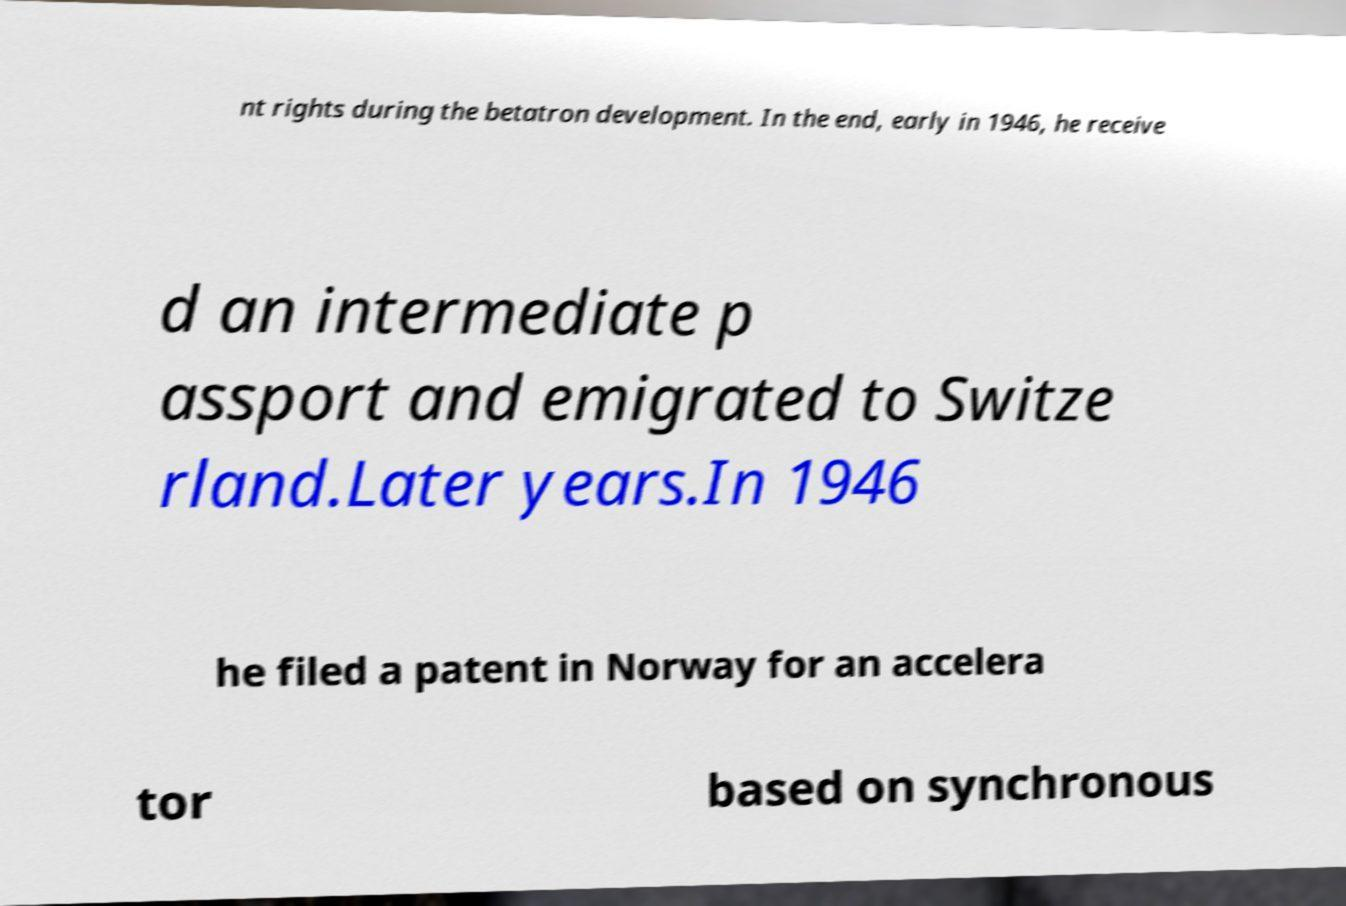What messages or text are displayed in this image? I need them in a readable, typed format. nt rights during the betatron development. In the end, early in 1946, he receive d an intermediate p assport and emigrated to Switze rland.Later years.In 1946 he filed a patent in Norway for an accelera tor based on synchronous 